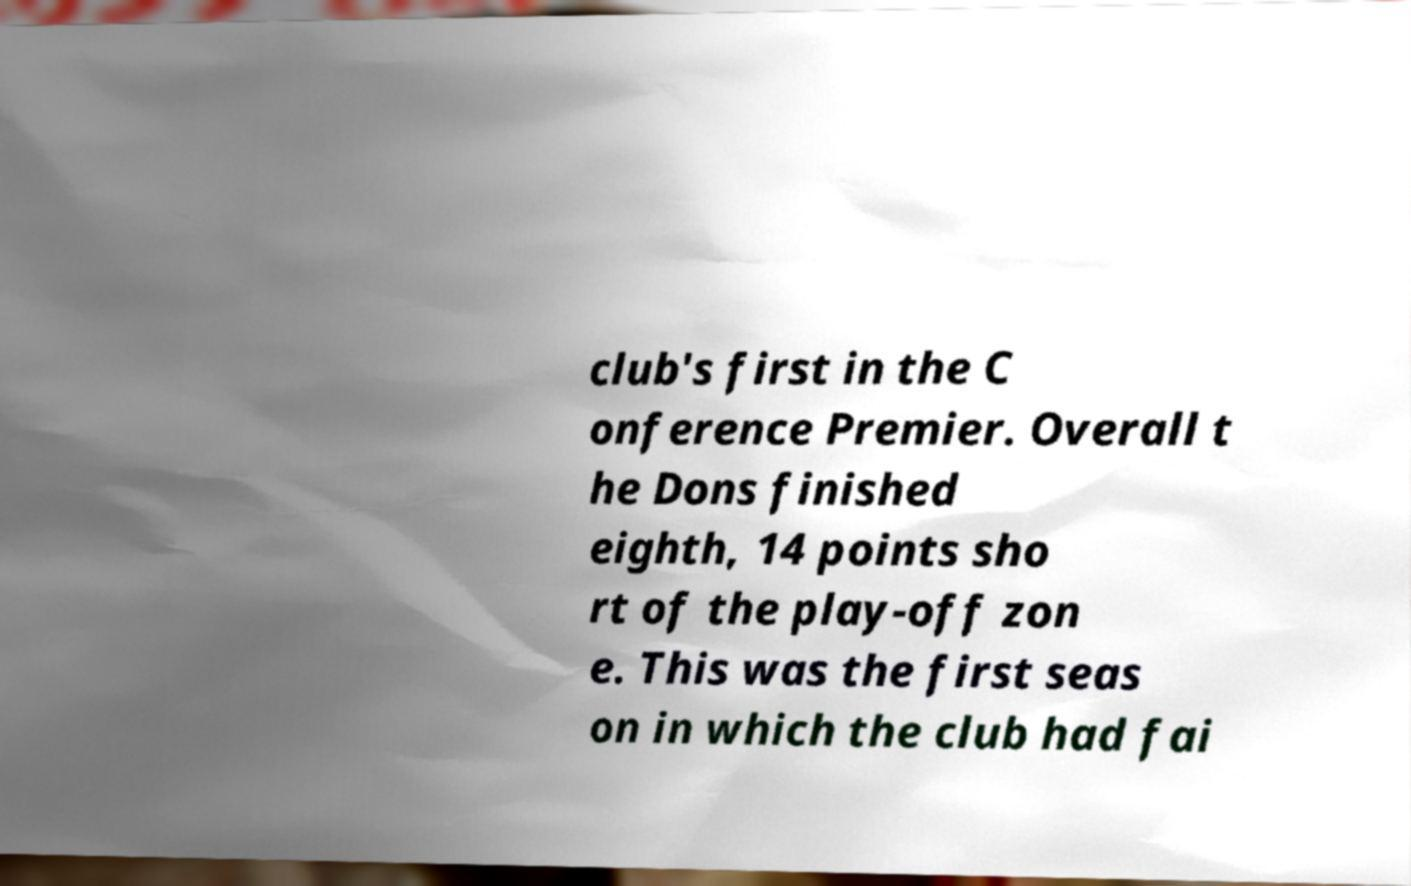I need the written content from this picture converted into text. Can you do that? club's first in the C onference Premier. Overall t he Dons finished eighth, 14 points sho rt of the play-off zon e. This was the first seas on in which the club had fai 